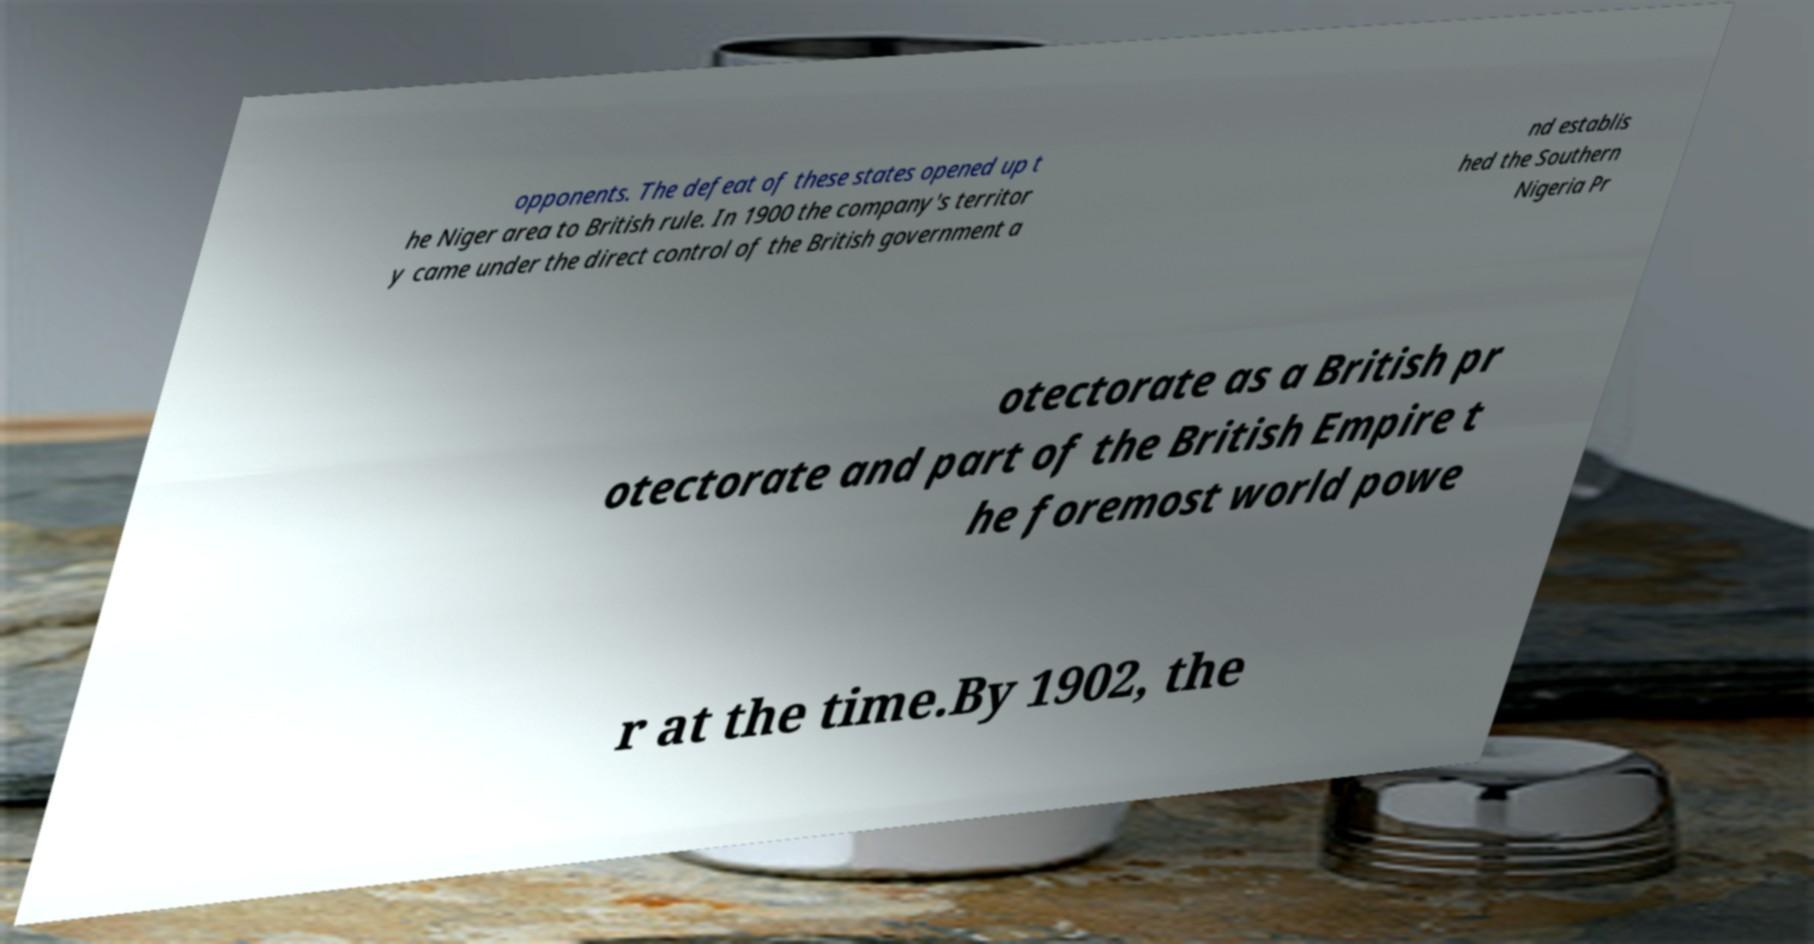There's text embedded in this image that I need extracted. Can you transcribe it verbatim? opponents. The defeat of these states opened up t he Niger area to British rule. In 1900 the company's territor y came under the direct control of the British government a nd establis hed the Southern Nigeria Pr otectorate as a British pr otectorate and part of the British Empire t he foremost world powe r at the time.By 1902, the 